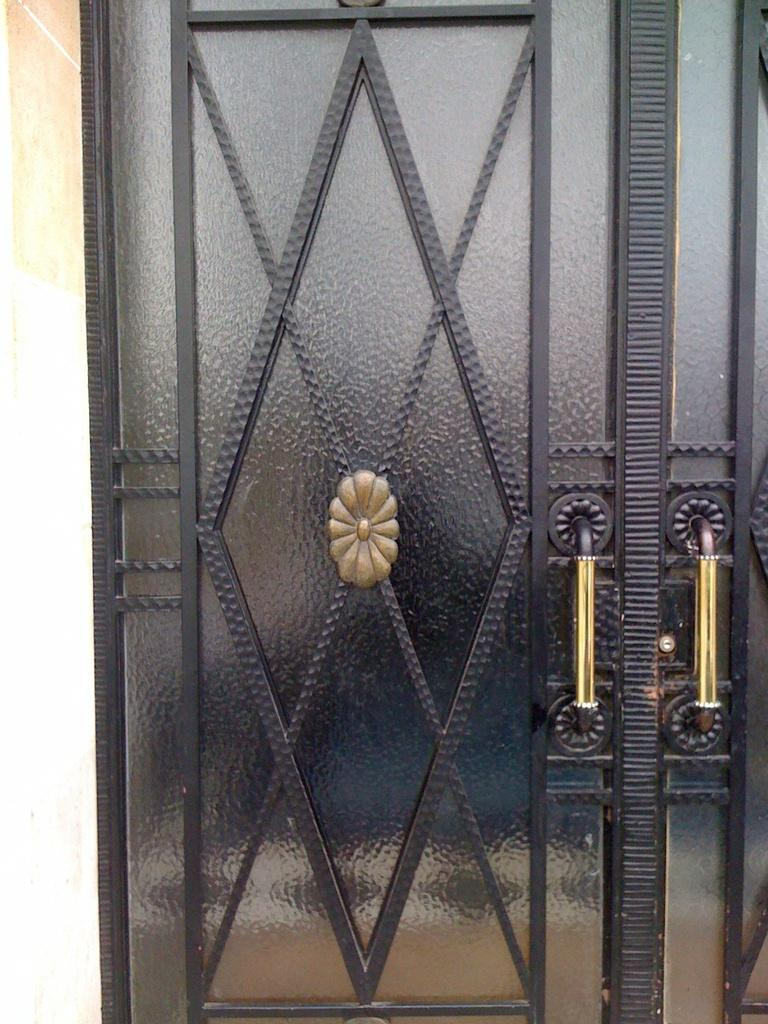What type of door is visible in the image? There is a metal door in the image. What colors are used for the metal door? The metal door is black and gold in color. What can be seen behind the metal door in the image? There is a cream-colored wall visible in the image. Can you see a monkey climbing on the metal door in the image? No, there is no monkey present in the image. What type of building is the metal door a part of in the image? The provided facts do not give any information about the building or its type. 